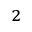Convert formula to latex. <formula><loc_0><loc_0><loc_500><loc_500>^ { 2 }</formula> 